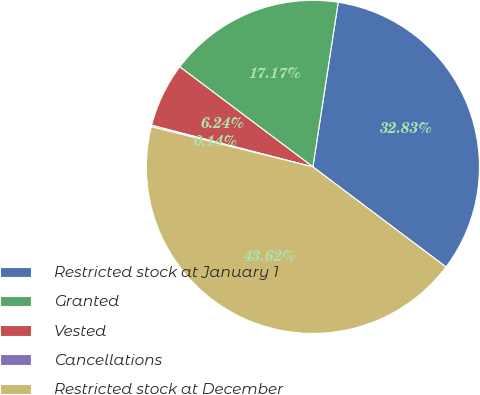Convert chart to OTSL. <chart><loc_0><loc_0><loc_500><loc_500><pie_chart><fcel>Restricted stock at January 1<fcel>Granted<fcel>Vested<fcel>Cancellations<fcel>Restricted stock at December<nl><fcel>32.83%<fcel>17.17%<fcel>6.24%<fcel>0.14%<fcel>43.62%<nl></chart> 